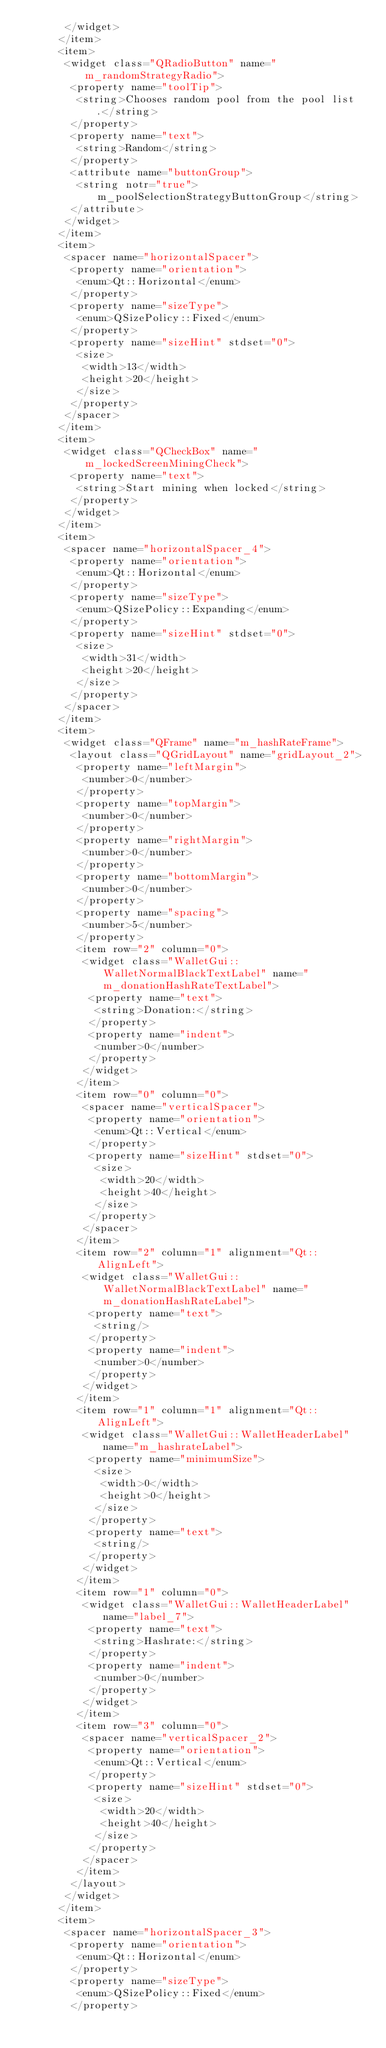Convert code to text. <code><loc_0><loc_0><loc_500><loc_500><_XML_>       </widget>
      </item>
      <item>
       <widget class="QRadioButton" name="m_randomStrategyRadio">
        <property name="toolTip">
         <string>Chooses random pool from the pool list.</string>
        </property>
        <property name="text">
         <string>Random</string>
        </property>
        <attribute name="buttonGroup">
         <string notr="true">m_poolSelectionStrategyButtonGroup</string>
        </attribute>
       </widget>
      </item>
      <item>
       <spacer name="horizontalSpacer">
        <property name="orientation">
         <enum>Qt::Horizontal</enum>
        </property>
        <property name="sizeType">
         <enum>QSizePolicy::Fixed</enum>
        </property>
        <property name="sizeHint" stdset="0">
         <size>
          <width>13</width>
          <height>20</height>
         </size>
        </property>
       </spacer>
      </item>
      <item>
       <widget class="QCheckBox" name="m_lockedScreenMiningCheck">
        <property name="text">
         <string>Start mining when locked</string>
        </property>
       </widget>
      </item>
      <item>
       <spacer name="horizontalSpacer_4">
        <property name="orientation">
         <enum>Qt::Horizontal</enum>
        </property>
        <property name="sizeType">
         <enum>QSizePolicy::Expanding</enum>
        </property>
        <property name="sizeHint" stdset="0">
         <size>
          <width>31</width>
          <height>20</height>
         </size>
        </property>
       </spacer>
      </item>
      <item>
       <widget class="QFrame" name="m_hashRateFrame">
        <layout class="QGridLayout" name="gridLayout_2">
         <property name="leftMargin">
          <number>0</number>
         </property>
         <property name="topMargin">
          <number>0</number>
         </property>
         <property name="rightMargin">
          <number>0</number>
         </property>
         <property name="bottomMargin">
          <number>0</number>
         </property>
         <property name="spacing">
          <number>5</number>
         </property>
         <item row="2" column="0">
          <widget class="WalletGui::WalletNormalBlackTextLabel" name="m_donationHashRateTextLabel">
           <property name="text">
            <string>Donation:</string>
           </property>
           <property name="indent">
            <number>0</number>
           </property>
          </widget>
         </item>
         <item row="0" column="0">
          <spacer name="verticalSpacer">
           <property name="orientation">
            <enum>Qt::Vertical</enum>
           </property>
           <property name="sizeHint" stdset="0">
            <size>
             <width>20</width>
             <height>40</height>
            </size>
           </property>
          </spacer>
         </item>
         <item row="2" column="1" alignment="Qt::AlignLeft">
          <widget class="WalletGui::WalletNormalBlackTextLabel" name="m_donationHashRateLabel">
           <property name="text">
            <string/>
           </property>
           <property name="indent">
            <number>0</number>
           </property>
          </widget>
         </item>
         <item row="1" column="1" alignment="Qt::AlignLeft">
          <widget class="WalletGui::WalletHeaderLabel" name="m_hashrateLabel">
           <property name="minimumSize">
            <size>
             <width>0</width>
             <height>0</height>
            </size>
           </property>
           <property name="text">
            <string/>
           </property>
          </widget>
         </item>
         <item row="1" column="0">
          <widget class="WalletGui::WalletHeaderLabel" name="label_7">
           <property name="text">
            <string>Hashrate:</string>
           </property>
           <property name="indent">
            <number>0</number>
           </property>
          </widget>
         </item>
         <item row="3" column="0">
          <spacer name="verticalSpacer_2">
           <property name="orientation">
            <enum>Qt::Vertical</enum>
           </property>
           <property name="sizeHint" stdset="0">
            <size>
             <width>20</width>
             <height>40</height>
            </size>
           </property>
          </spacer>
         </item>
        </layout>
       </widget>
      </item>
      <item>
       <spacer name="horizontalSpacer_3">
        <property name="orientation">
         <enum>Qt::Horizontal</enum>
        </property>
        <property name="sizeType">
         <enum>QSizePolicy::Fixed</enum>
        </property></code> 